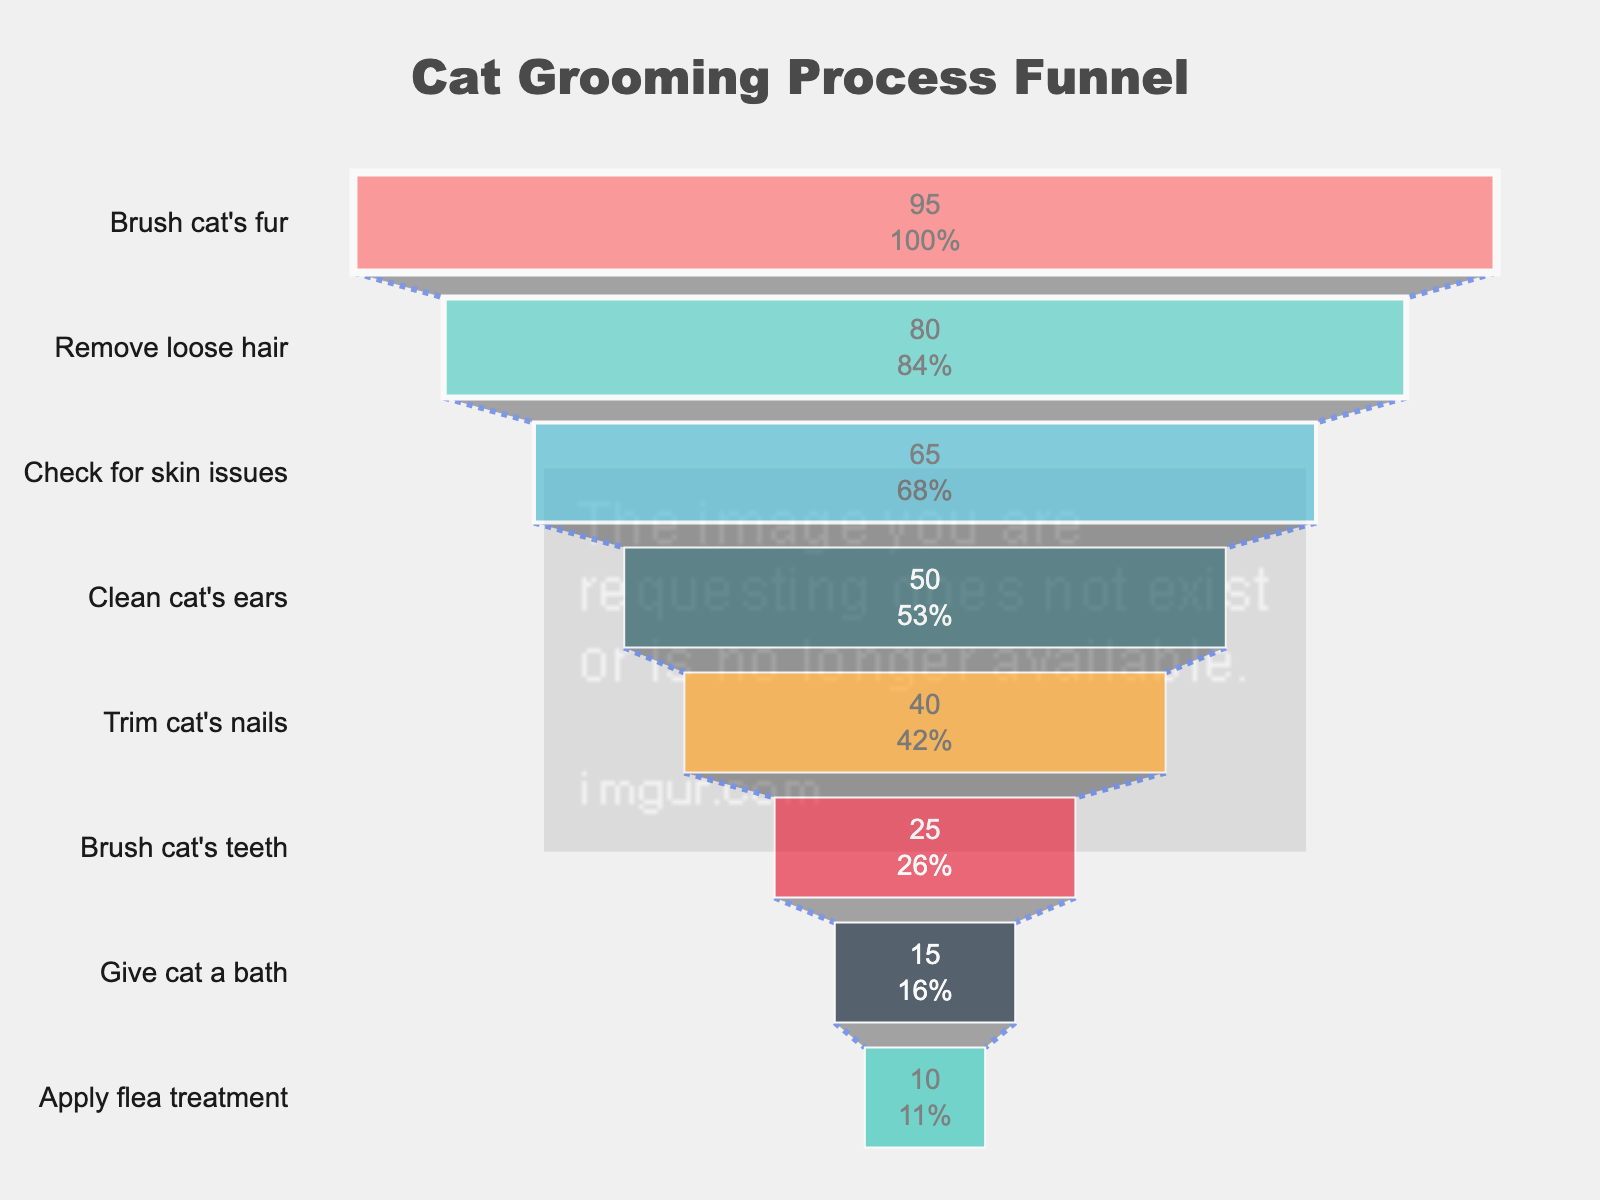What is the title of the funnel chart? The title is the text displayed prominently at the top of the chart, usually summarizing the chart's purpose. In this case, the title is "Cat Grooming Process Funnel."
Answer: Cat Grooming Process Funnel Which step has the highest percentage of cat owners completing it? The bar at the top of the funnel represents the highest percentage. This step is "Brush cat's fur," with 95%.
Answer: Brush cat's fur How many steps are shown in the cat grooming process funnel? Counting the bars in the funnel chart, there are a total of 8 steps shown.
Answer: 8 What percentage of cat owners complete cleaning their cat's ears? The bar labeled "Clean cat's ears" shows the percentage of cat owners who complete this step, which is 50%.
Answer: 50% What is the percentage difference between the steps of trimming cat's nails and giving a cat a bath? The percentage for trimming cat's nails is 40% and giving a cat a bath is 15%. The difference is 40% - 15%, which equals 25%.
Answer: 25% Which step has the lowest percentage completion among cat owners? The lowest bar in the funnel chart represents the step with the lowest percentage. This step is "Apply flea treatment," with 10%.
Answer: Apply flea treatment Rank the middle three steps according to their completion percentages. The middle three steps are identified by their positions in the funnel, and are ranked from highest to lowest percentage as: "Check for skin issues" (65%), "Clean cat's ears" (50%), "Trim cat's nails" (40%).
Answer: Check for skin issues, Clean cat's ears, Trim cat's nails What percentage of cat owners brush their cat's teeth compared to those who give their cat a bath? The funnel shows 25% of cat owners brush their cat's teeth and 15% give their cat a bath. Comparing these two steps: 25% is greater than 15%.
Answer: 25% is greater What is the total sum of percentages for all steps? Summing up the percentages for all the steps: 95% + 80% + 65% + 50% + 40% + 25% + 15% + 10% = 380%.
Answer: 380% Does more than half of the cat owners check for skin issues? The percentage of cat owners who check for skin issues is 65%, which is more than half.
Answer: Yes 